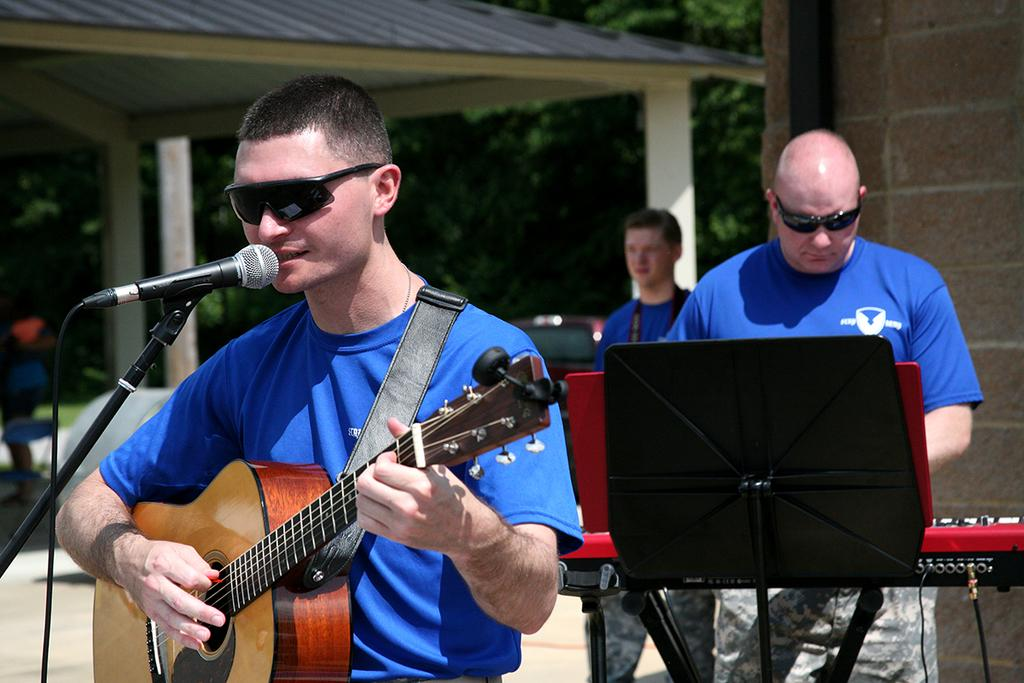What is the main subject of the image? There is a person in the image. What is the person doing in the image? The person is sitting. What object is the person holding in the image? The person is holding a mic in his hand. What type of quartz can be seen in the person's hand in the image? There is no quartz present in the image; the person is holding a mic. What effect does the mic have on the person's voice in the image? The image does not show the person speaking or using the mic, so it is not possible to determine the effect on their voice. 